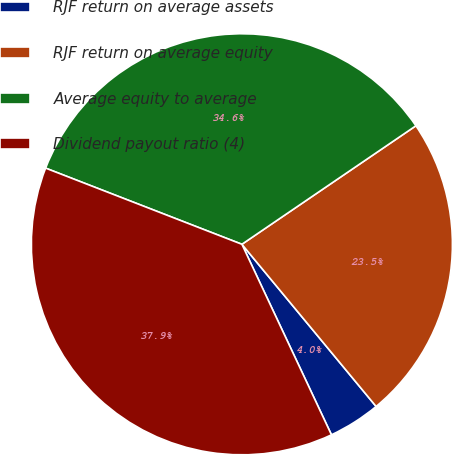Convert chart to OTSL. <chart><loc_0><loc_0><loc_500><loc_500><pie_chart><fcel>RJF return on average assets<fcel>RJF return on average equity<fcel>Average equity to average<fcel>Dividend payout ratio (4)<nl><fcel>4.01%<fcel>23.51%<fcel>34.59%<fcel>37.88%<nl></chart> 